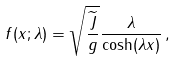Convert formula to latex. <formula><loc_0><loc_0><loc_500><loc_500>f ( x ; \lambda ) = \sqrt { \frac { \widetilde { J } } { g } } \frac { \lambda } { \cosh ( \lambda x ) } \, ,</formula> 